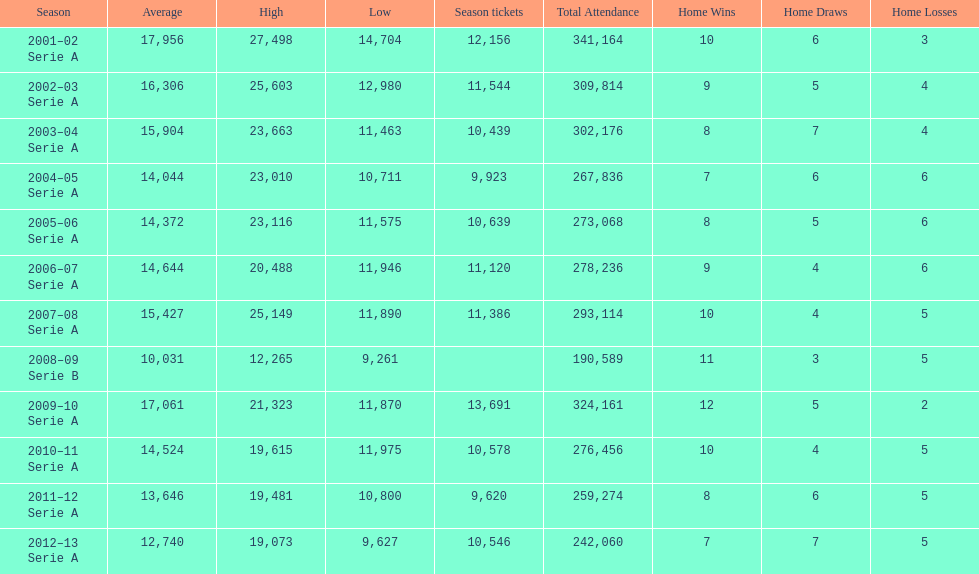Could you parse the entire table? {'header': ['Season', 'Average', 'High', 'Low', 'Season tickets', 'Total Attendance', 'Home Wins', 'Home Draws', 'Home Losses'], 'rows': [['2001–02 Serie A', '17,956', '27,498', '14,704', '12,156', '341,164', '10', '6', '3'], ['2002–03 Serie A', '16,306', '25,603', '12,980', '11,544', '309,814', '9', '5', '4'], ['2003–04 Serie A', '15,904', '23,663', '11,463', '10,439', '302,176', '8', '7', '4'], ['2004–05 Serie A', '14,044', '23,010', '10,711', '9,923', '267,836', '7', '6', '6'], ['2005–06 Serie A', '14,372', '23,116', '11,575', '10,639', '273,068', '8', '5', '6'], ['2006–07 Serie A', '14,644', '20,488', '11,946', '11,120', '278,236', '9', '4', '6'], ['2007–08 Serie A', '15,427', '25,149', '11,890', '11,386', '293,114', '10', '4', '5'], ['2008–09 Serie B', '10,031', '12,265', '9,261', '', '190,589', '11', '3', '5'], ['2009–10 Serie A', '17,061', '21,323', '11,870', '13,691', '324,161', '12', '5', '2'], ['2010–11 Serie A', '14,524', '19,615', '11,975', '10,578', '276,456', '10', '4', '5'], ['2011–12 Serie A', '13,646', '19,481', '10,800', '9,620', '259,274', '8', '6', '5'], ['2012–13 Serie A', '12,740', '19,073', '9,627', '10,546', '242,060', '7', '7', '5']]} How many seasons at the stadio ennio tardini had 11,000 or more season tickets? 5. 